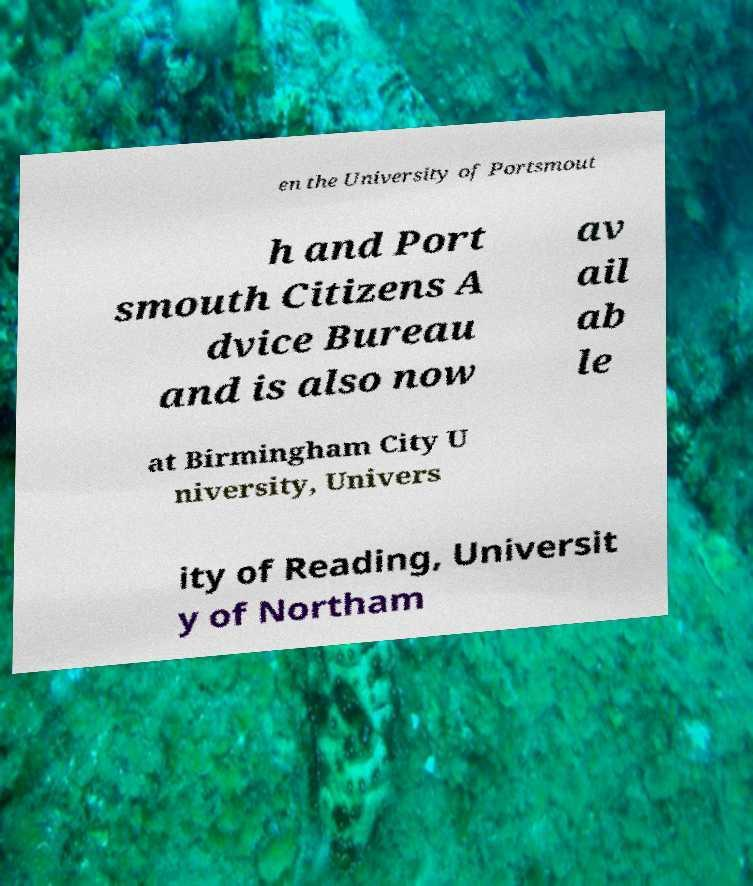What messages or text are displayed in this image? I need them in a readable, typed format. en the University of Portsmout h and Port smouth Citizens A dvice Bureau and is also now av ail ab le at Birmingham City U niversity, Univers ity of Reading, Universit y of Northam 